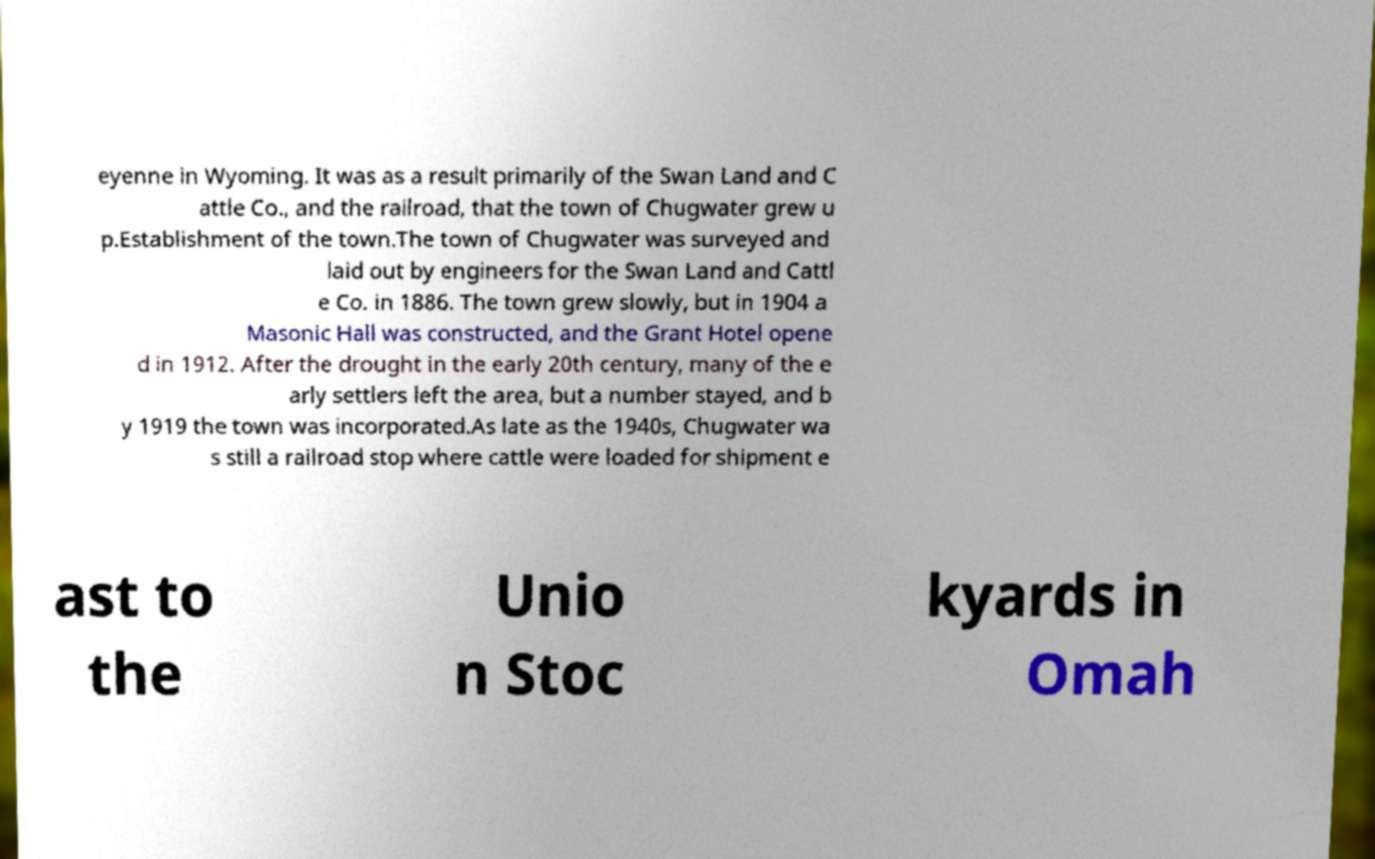What messages or text are displayed in this image? I need them in a readable, typed format. eyenne in Wyoming. It was as a result primarily of the Swan Land and C attle Co., and the railroad, that the town of Chugwater grew u p.Establishment of the town.The town of Chugwater was surveyed and laid out by engineers for the Swan Land and Cattl e Co. in 1886. The town grew slowly, but in 1904 a Masonic Hall was constructed, and the Grant Hotel opene d in 1912. After the drought in the early 20th century, many of the e arly settlers left the area, but a number stayed, and b y 1919 the town was incorporated.As late as the 1940s, Chugwater wa s still a railroad stop where cattle were loaded for shipment e ast to the Unio n Stoc kyards in Omah 